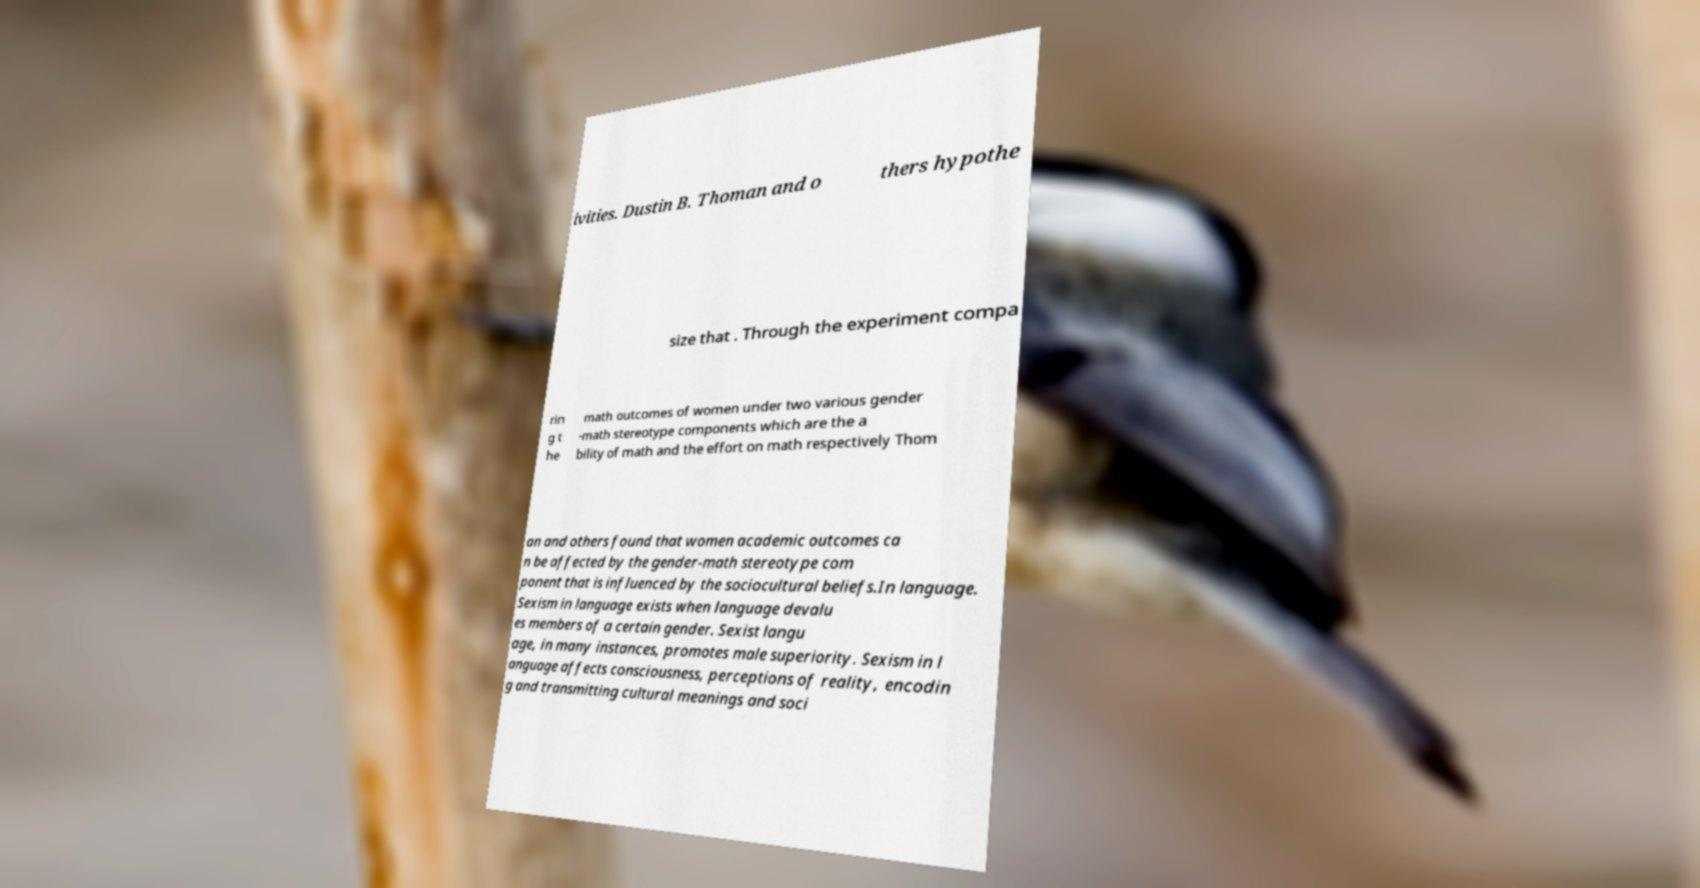For documentation purposes, I need the text within this image transcribed. Could you provide that? ivities. Dustin B. Thoman and o thers hypothe size that . Through the experiment compa rin g t he math outcomes of women under two various gender -math stereotype components which are the a bility of math and the effort on math respectively Thom an and others found that women academic outcomes ca n be affected by the gender-math stereotype com ponent that is influenced by the sociocultural beliefs.In language. Sexism in language exists when language devalu es members of a certain gender. Sexist langu age, in many instances, promotes male superiority. Sexism in l anguage affects consciousness, perceptions of reality, encodin g and transmitting cultural meanings and soci 